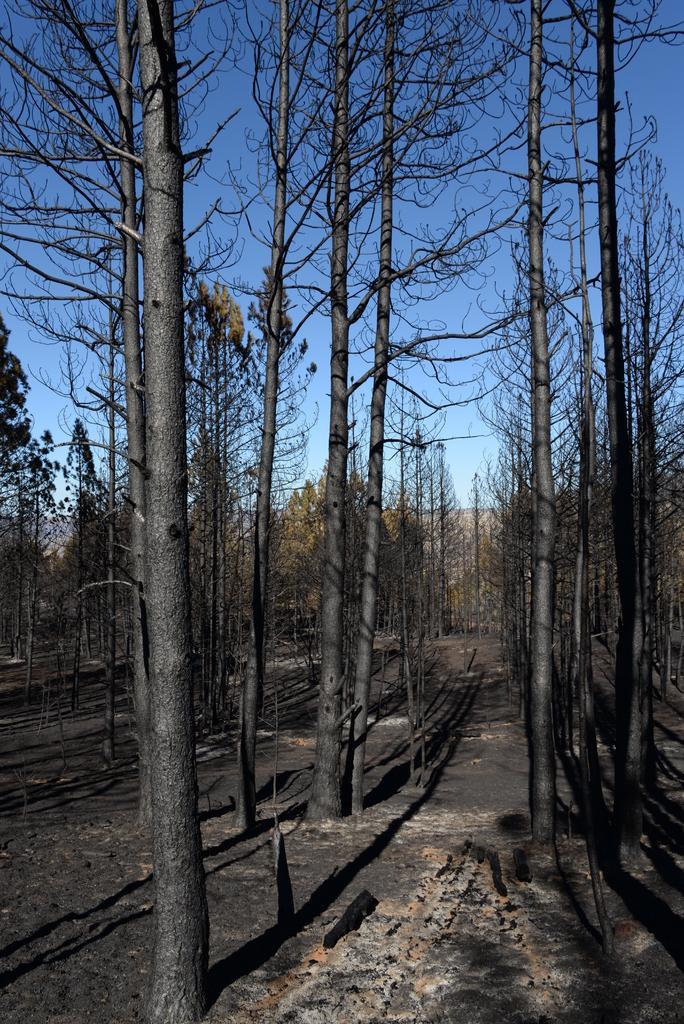Can you describe this image briefly? In this image we can see some trees, also we can see the sky. 